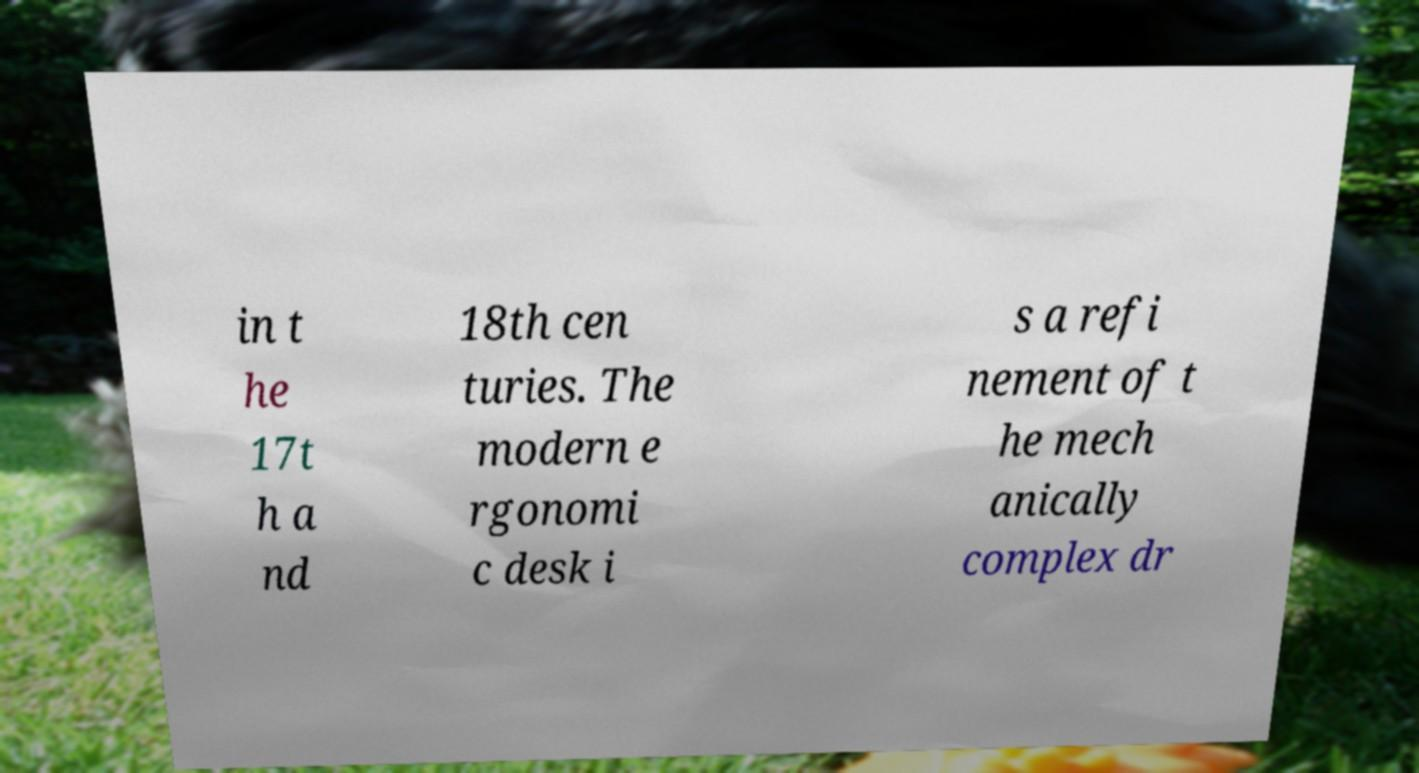I need the written content from this picture converted into text. Can you do that? in t he 17t h a nd 18th cen turies. The modern e rgonomi c desk i s a refi nement of t he mech anically complex dr 